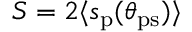Convert formula to latex. <formula><loc_0><loc_0><loc_500><loc_500>S = 2 \langle s _ { p } ( \theta _ { p s } ) \rangle</formula> 